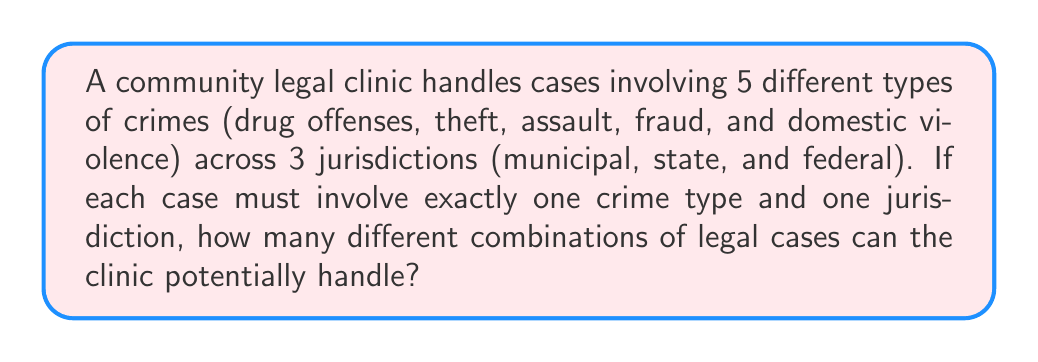Provide a solution to this math problem. To solve this problem, we'll use the multiplication principle of counting. Here's the step-by-step explanation:

1) We have two independent choices to make for each case:
   - The type of crime (5 options)
   - The jurisdiction (3 options)

2) For each crime type, we can choose any of the 3 jurisdictions. This means that for each crime type, we have 3 possible combinations.

3) We have 5 different crime types, and for each of these, we have 3 choices of jurisdiction.

4) Therefore, we can calculate the total number of combinations using the multiplication principle:

   $$ \text{Total combinations} = \text{Number of crime types} \times \text{Number of jurisdictions} $$

   $$ \text{Total combinations} = 5 \times 3 = 15 $$

This means that there are 15 different possible combinations of legal cases that the clinic can potentially handle.
Answer: 15 combinations 